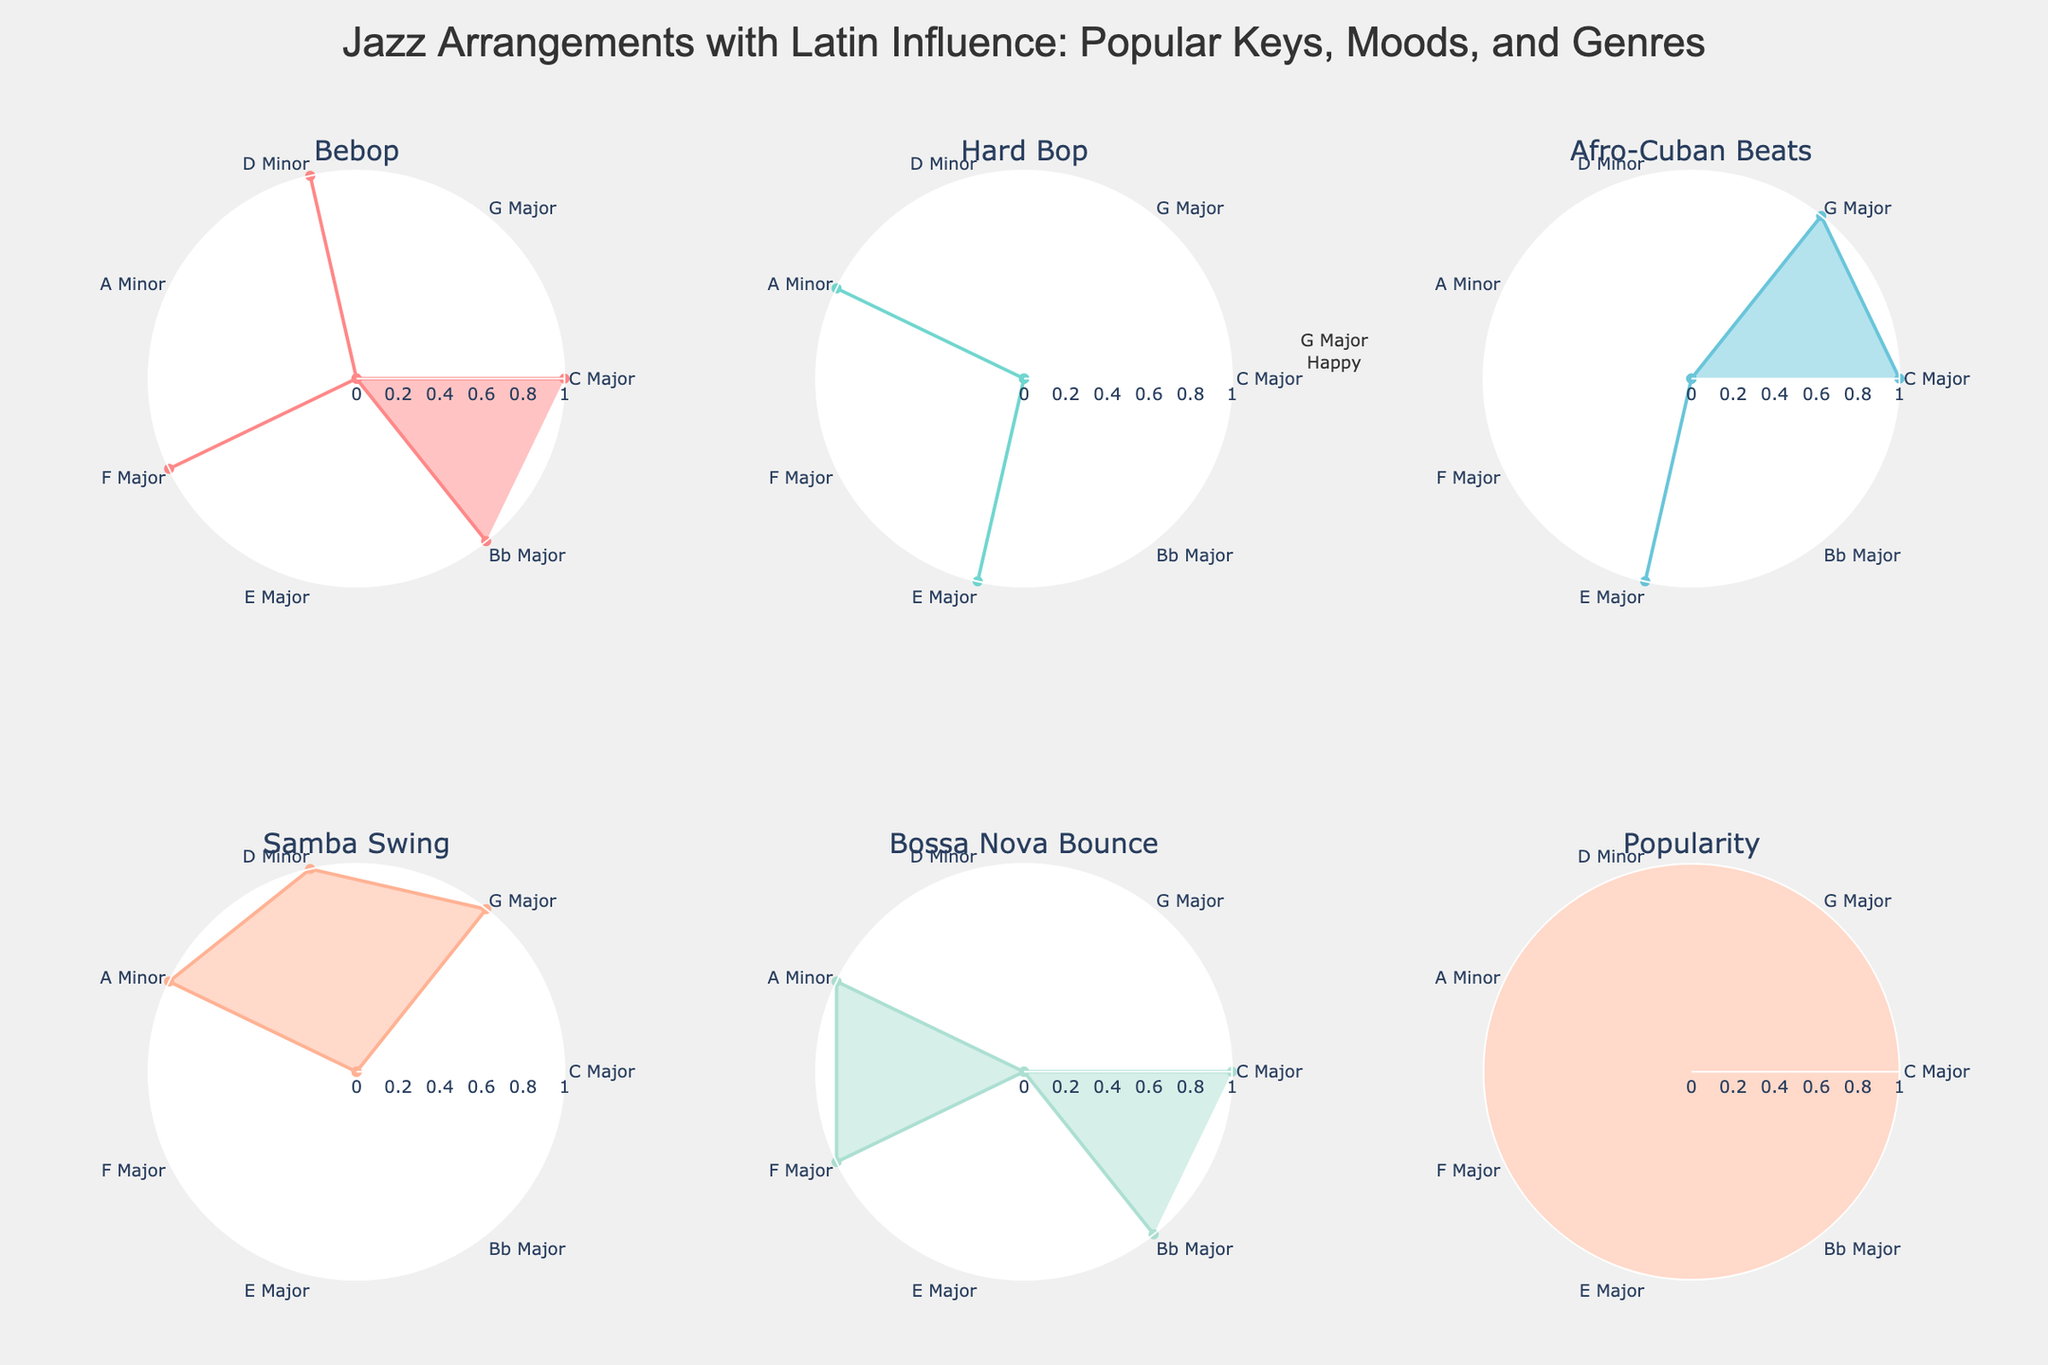What's the most popular key in the arrangements? The popularity subplot shows the highest value reaching 75 at F Major.
Answer: F Major Which mood is associated with the least popular key? The popularity subplot shows the lowest value reaching 45 at E Major, which corresponds to the Groovy mood.
Answer: Groovy Which genre has contributions from C Major in Bebop or Hard Bop? For the genres Bebop and Hard Bop subplots, C Major has contributions only to Bebop as shown by the presence of a marker for Bebop only.
Answer: Bebop How many keys contribute to the Bossa Nova Bounce genre? Count the number of data points in the Bossa Nova Bounce subplot; there are 3 contributions from C Major, A Minor, and Bb Major.
Answer: 3 What is the combined popularity score for minor keys in the arrangements? The popularity scores for minor keys are D Minor (55) and A Minor (60). Sum these values: 55 + 60.
Answer: 115 Compare the number of major keys contributing to Afro-Cuban Beats and Samba Swing. Which category has more? Afro-Cuban Beats includes C Major, G Major, and E Major (3 keys). Samba Swing includes G Major, D Minor, and A Minor (2 major keys: G Major and D Minor). Afro-Cuban Beats has more major keys.
Answer: Afro-Cuban Beats Do any keys contribute to all genres? C Major appears in Bebop, Afro-Cuban Beats, and Bossa Nova Bounce, but is not present in Hard Bop or Samba Swing. No key contributes to all genres.
Answer: No What key and mood are associated with the maximal contribution to the Bossa Nova Bounce? In the Bossa Nova Bounce subplot, F Major has a significant presence, being associated with the Relaxed mood.
Answer: F Major, Relaxed Which genre shows no contribution from the D Minor key? The D Minor is present in Bebop and Samba Swing; however, it is not present in Hard Bop, Afro-Cuban Beats, or Bossa Nova Bounce.
Answer: Hard Bop, Afro-Cuban Beats, and Bossa Nova Bounce 